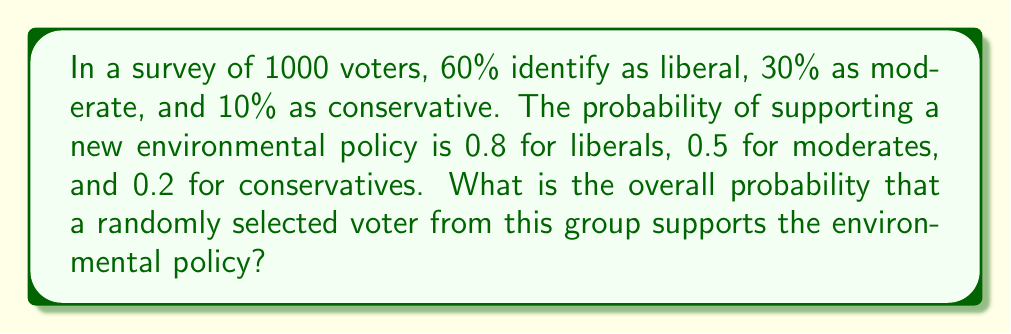Teach me how to tackle this problem. To solve this problem, we'll use the law of total probability. Let's break it down step-by-step:

1) Define events:
   L: voter is liberal
   M: voter is moderate
   C: voter is conservative
   S: voter supports the policy

2) Given probabilities:
   $P(L) = 0.60$, $P(M) = 0.30$, $P(C) = 0.10$
   $P(S|L) = 0.80$, $P(S|M) = 0.50$, $P(S|C) = 0.20$

3) Law of Total Probability:
   $$P(S) = P(S|L) \cdot P(L) + P(S|M) \cdot P(M) + P(S|C) \cdot P(C)$$

4) Substitute the values:
   $$P(S) = (0.80 \cdot 0.60) + (0.50 \cdot 0.30) + (0.20 \cdot 0.10)$$

5) Calculate:
   $$P(S) = 0.48 + 0.15 + 0.02 = 0.65$$

Therefore, the probability that a randomly selected voter supports the policy is 0.65 or 65%.
Answer: 0.65 